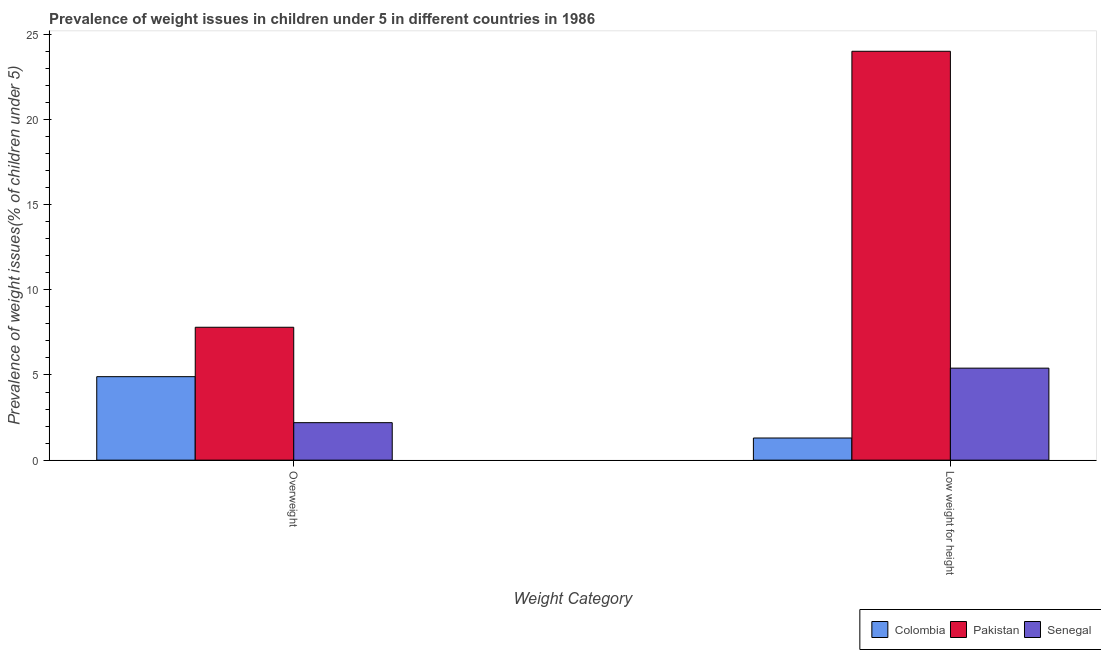How many different coloured bars are there?
Provide a succinct answer. 3. How many groups of bars are there?
Give a very brief answer. 2. Are the number of bars per tick equal to the number of legend labels?
Ensure brevity in your answer.  Yes. How many bars are there on the 2nd tick from the left?
Your answer should be very brief. 3. How many bars are there on the 1st tick from the right?
Offer a very short reply. 3. What is the label of the 2nd group of bars from the left?
Make the answer very short. Low weight for height. What is the percentage of overweight children in Colombia?
Make the answer very short. 4.9. Across all countries, what is the maximum percentage of underweight children?
Your response must be concise. 24. Across all countries, what is the minimum percentage of overweight children?
Give a very brief answer. 2.2. In which country was the percentage of underweight children maximum?
Give a very brief answer. Pakistan. In which country was the percentage of overweight children minimum?
Your answer should be very brief. Senegal. What is the total percentage of underweight children in the graph?
Ensure brevity in your answer.  30.7. What is the difference between the percentage of overweight children in Pakistan and that in Colombia?
Ensure brevity in your answer.  2.9. What is the difference between the percentage of overweight children in Colombia and the percentage of underweight children in Pakistan?
Provide a succinct answer. -19.1. What is the average percentage of overweight children per country?
Keep it short and to the point. 4.97. What is the difference between the percentage of underweight children and percentage of overweight children in Pakistan?
Your response must be concise. 16.2. In how many countries, is the percentage of underweight children greater than 23 %?
Provide a succinct answer. 1. What is the ratio of the percentage of underweight children in Senegal to that in Pakistan?
Your answer should be very brief. 0.23. In how many countries, is the percentage of underweight children greater than the average percentage of underweight children taken over all countries?
Provide a short and direct response. 1. What does the 1st bar from the left in Low weight for height represents?
Offer a terse response. Colombia. What does the 1st bar from the right in Overweight represents?
Offer a very short reply. Senegal. Are all the bars in the graph horizontal?
Make the answer very short. No. What is the difference between two consecutive major ticks on the Y-axis?
Offer a terse response. 5. Does the graph contain any zero values?
Keep it short and to the point. No. How many legend labels are there?
Your answer should be compact. 3. How are the legend labels stacked?
Ensure brevity in your answer.  Horizontal. What is the title of the graph?
Offer a very short reply. Prevalence of weight issues in children under 5 in different countries in 1986. Does "Myanmar" appear as one of the legend labels in the graph?
Your answer should be very brief. No. What is the label or title of the X-axis?
Make the answer very short. Weight Category. What is the label or title of the Y-axis?
Make the answer very short. Prevalence of weight issues(% of children under 5). What is the Prevalence of weight issues(% of children under 5) of Colombia in Overweight?
Offer a very short reply. 4.9. What is the Prevalence of weight issues(% of children under 5) of Pakistan in Overweight?
Ensure brevity in your answer.  7.8. What is the Prevalence of weight issues(% of children under 5) in Senegal in Overweight?
Your answer should be compact. 2.2. What is the Prevalence of weight issues(% of children under 5) in Colombia in Low weight for height?
Make the answer very short. 1.3. What is the Prevalence of weight issues(% of children under 5) of Pakistan in Low weight for height?
Ensure brevity in your answer.  24. What is the Prevalence of weight issues(% of children under 5) in Senegal in Low weight for height?
Offer a very short reply. 5.4. Across all Weight Category, what is the maximum Prevalence of weight issues(% of children under 5) of Colombia?
Offer a terse response. 4.9. Across all Weight Category, what is the maximum Prevalence of weight issues(% of children under 5) in Senegal?
Make the answer very short. 5.4. Across all Weight Category, what is the minimum Prevalence of weight issues(% of children under 5) of Colombia?
Your answer should be very brief. 1.3. Across all Weight Category, what is the minimum Prevalence of weight issues(% of children under 5) in Pakistan?
Your answer should be very brief. 7.8. Across all Weight Category, what is the minimum Prevalence of weight issues(% of children under 5) of Senegal?
Make the answer very short. 2.2. What is the total Prevalence of weight issues(% of children under 5) in Colombia in the graph?
Your answer should be compact. 6.2. What is the total Prevalence of weight issues(% of children under 5) of Pakistan in the graph?
Provide a succinct answer. 31.8. What is the difference between the Prevalence of weight issues(% of children under 5) of Pakistan in Overweight and that in Low weight for height?
Provide a succinct answer. -16.2. What is the difference between the Prevalence of weight issues(% of children under 5) in Senegal in Overweight and that in Low weight for height?
Provide a short and direct response. -3.2. What is the difference between the Prevalence of weight issues(% of children under 5) of Colombia in Overweight and the Prevalence of weight issues(% of children under 5) of Pakistan in Low weight for height?
Provide a short and direct response. -19.1. What is the average Prevalence of weight issues(% of children under 5) of Senegal per Weight Category?
Offer a terse response. 3.8. What is the difference between the Prevalence of weight issues(% of children under 5) of Colombia and Prevalence of weight issues(% of children under 5) of Pakistan in Overweight?
Ensure brevity in your answer.  -2.9. What is the difference between the Prevalence of weight issues(% of children under 5) of Colombia and Prevalence of weight issues(% of children under 5) of Senegal in Overweight?
Your response must be concise. 2.7. What is the difference between the Prevalence of weight issues(% of children under 5) of Pakistan and Prevalence of weight issues(% of children under 5) of Senegal in Overweight?
Your answer should be very brief. 5.6. What is the difference between the Prevalence of weight issues(% of children under 5) of Colombia and Prevalence of weight issues(% of children under 5) of Pakistan in Low weight for height?
Ensure brevity in your answer.  -22.7. What is the difference between the Prevalence of weight issues(% of children under 5) of Pakistan and Prevalence of weight issues(% of children under 5) of Senegal in Low weight for height?
Your response must be concise. 18.6. What is the ratio of the Prevalence of weight issues(% of children under 5) of Colombia in Overweight to that in Low weight for height?
Your answer should be compact. 3.77. What is the ratio of the Prevalence of weight issues(% of children under 5) in Pakistan in Overweight to that in Low weight for height?
Give a very brief answer. 0.33. What is the ratio of the Prevalence of weight issues(% of children under 5) in Senegal in Overweight to that in Low weight for height?
Ensure brevity in your answer.  0.41. What is the difference between the highest and the second highest Prevalence of weight issues(% of children under 5) of Colombia?
Your answer should be very brief. 3.6. What is the difference between the highest and the lowest Prevalence of weight issues(% of children under 5) of Colombia?
Ensure brevity in your answer.  3.6. What is the difference between the highest and the lowest Prevalence of weight issues(% of children under 5) of Pakistan?
Provide a short and direct response. 16.2. What is the difference between the highest and the lowest Prevalence of weight issues(% of children under 5) in Senegal?
Offer a very short reply. 3.2. 